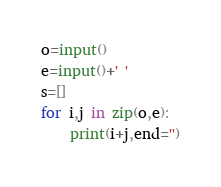<code> <loc_0><loc_0><loc_500><loc_500><_Python_>o=input()
e=input()+' '
s=[]
for i,j in zip(o,e):
    print(i+j,end='')</code> 